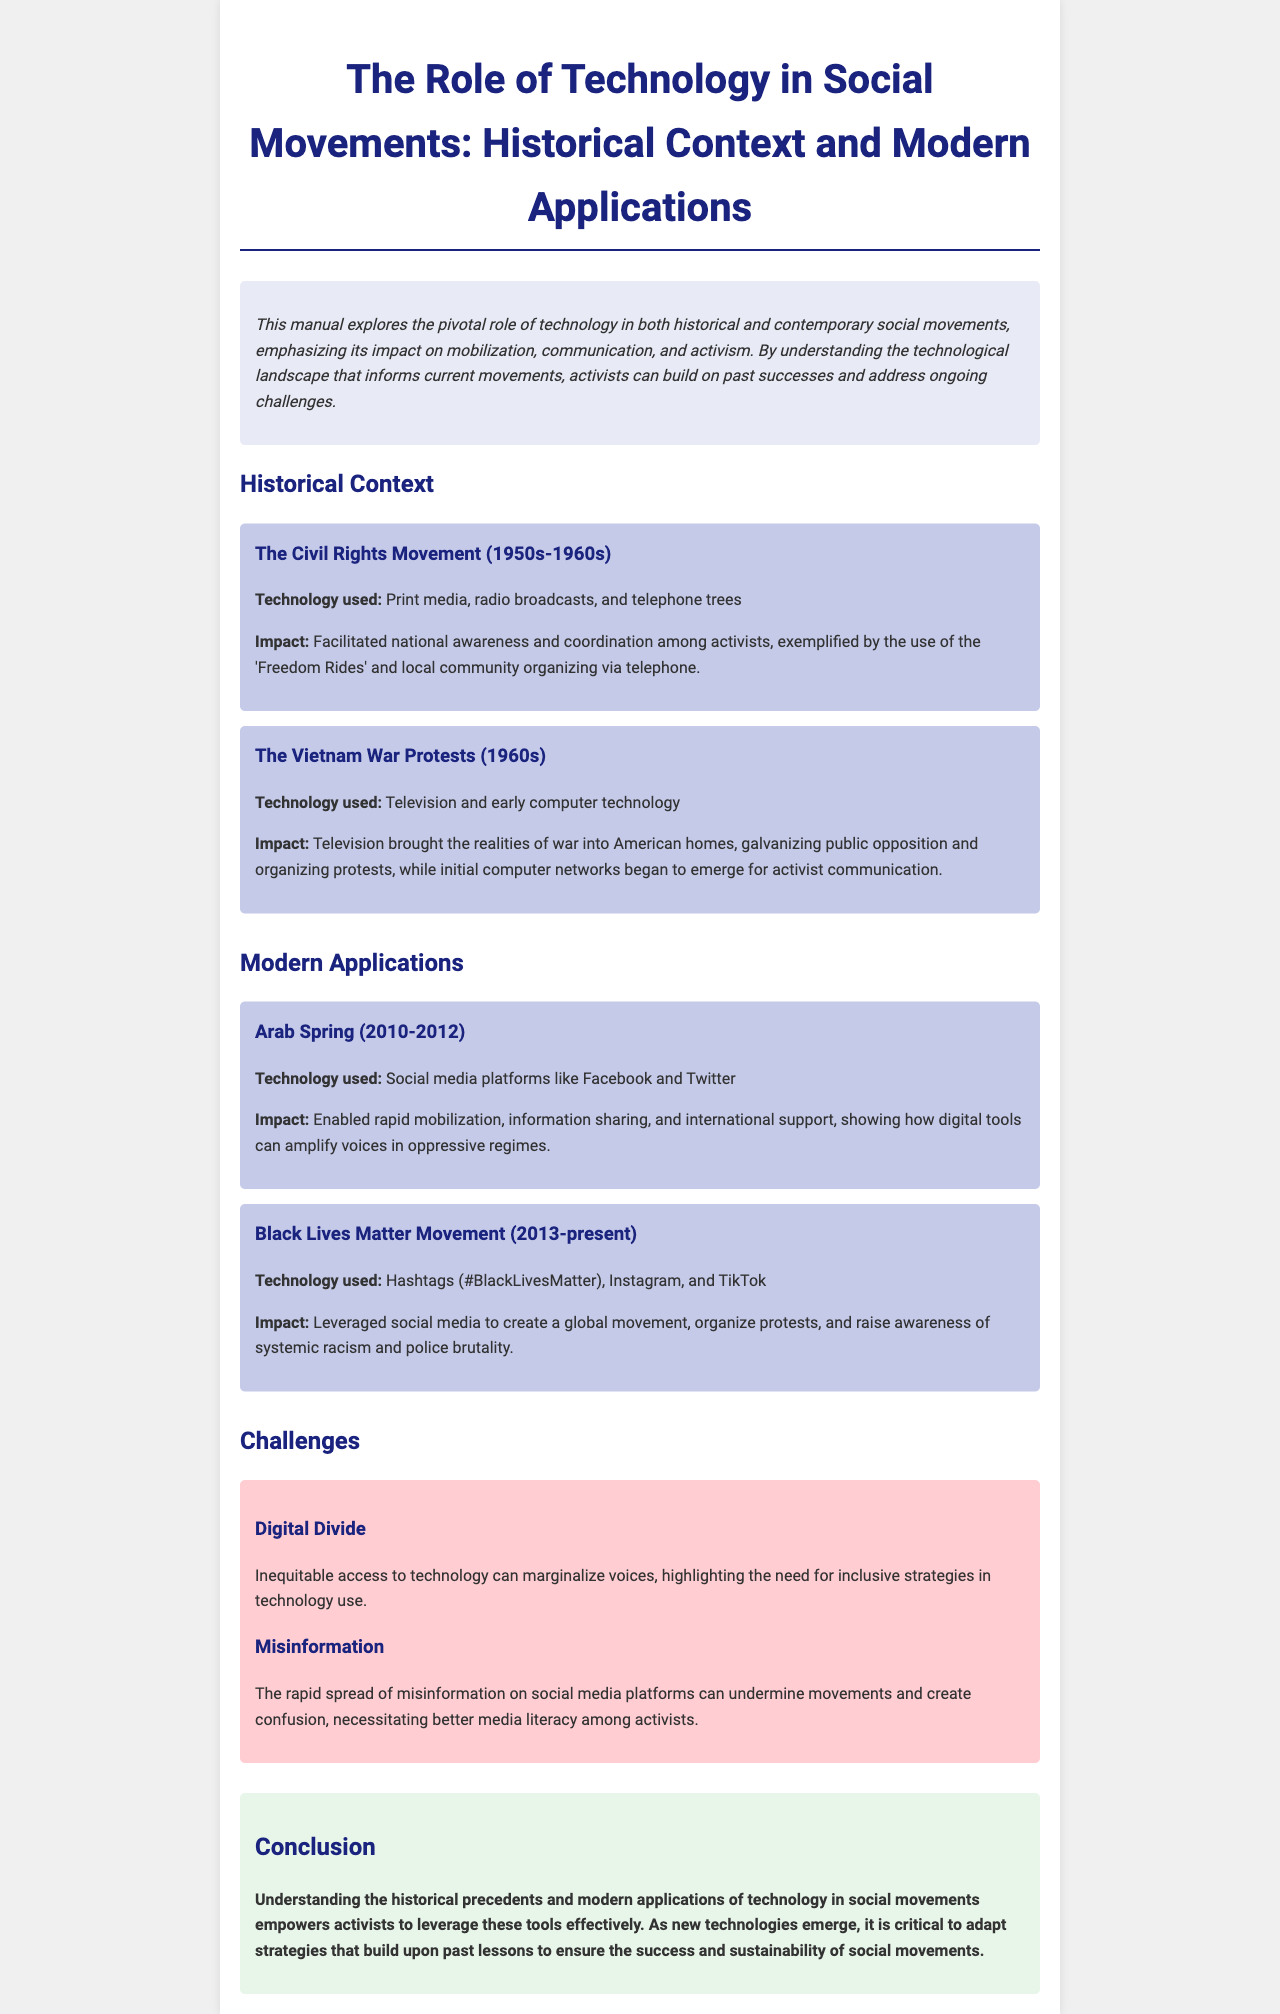What technology was used in the Civil Rights Movement? The document lists the technology used during the Civil Rights Movement as print media, radio broadcasts, and telephone trees.
Answer: Print media, radio broadcasts, and telephone trees What year did the Black Lives Matter movement begin? According to the document, the Black Lives Matter movement started in 2013.
Answer: 2013 What role did television play during the Vietnam War Protests? The document states that television brought the realities of war into American homes, galvanizing public opposition and organizing protests.
Answer: Galvanizing public opposition What technology was prominent during the Arab Spring? The document mentions social media platforms like Facebook and Twitter as key technologies during the Arab Spring.
Answer: Facebook and Twitter What is one challenge mentioned related to technology in social movements? The document highlights the digital divide as one of the challenges organizations face in technology use.
Answer: Digital Divide How does the document suggest activists should respond to misinformation? The document suggests that better media literacy among activists is necessary to combat misinformation on social media.
Answer: Better media literacy What emphasizes the impact of technology on movements in the conclusion? The conclusion stresses that understanding historical precedents and modern applications empowers activists to leverage technology effectively.
Answer: Empowers activists What was a notable incident facilitated by telephone trees during the Civil Rights Movement? The document refers to the use of 'Freedom Rides' coordinated through telephone trees in the Civil Rights Movement.
Answer: Freedom Rides What is a significant technology listed for the Black Lives Matter movement? The document identifies the use of hashtags, specifically #BlackLivesMatter, as a significant technology for the movement.
Answer: #BlackLivesMatter 